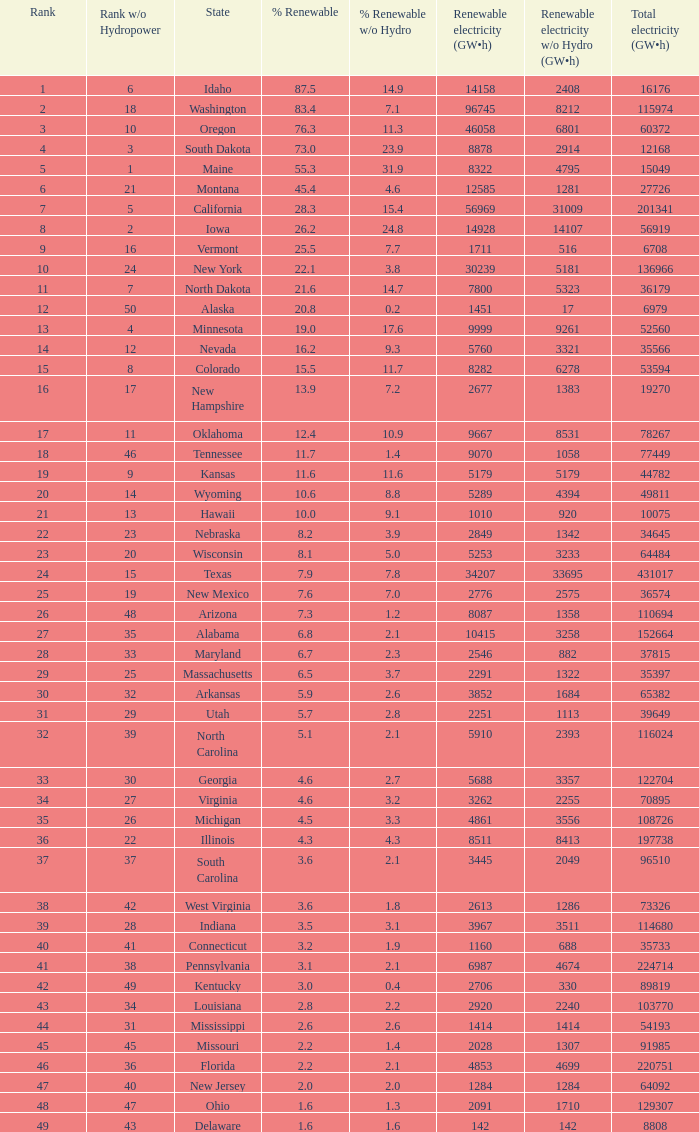What is the percentage of renewable electricity without hydrogen power in the state of South Dakota? 23.9. 